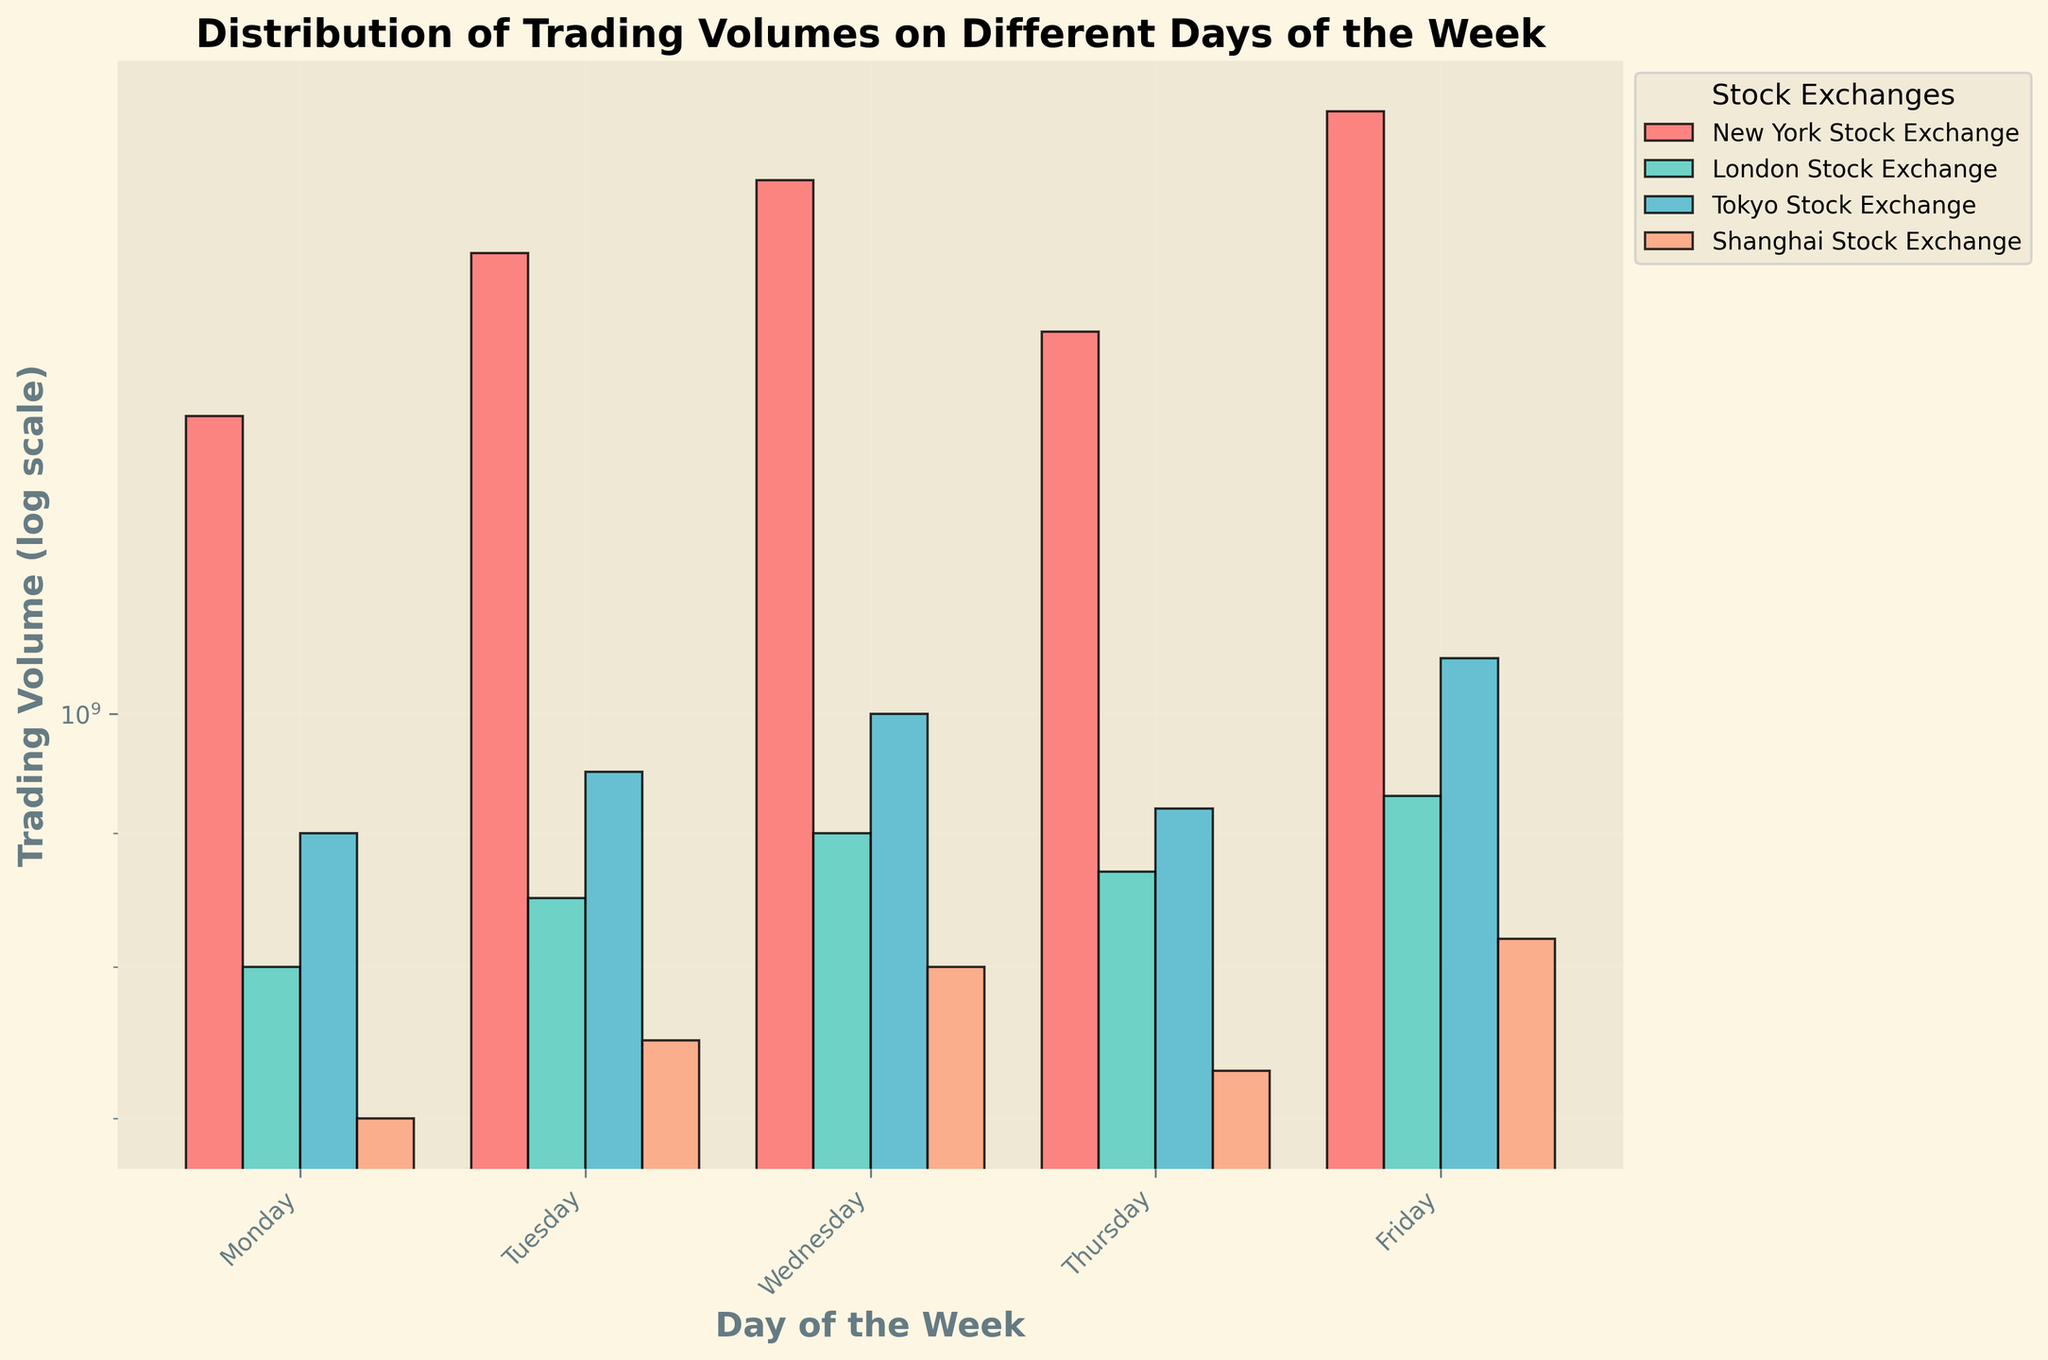Which market has the highest trading volume on Friday? By looking at the bars for Friday, the market with the tallest bar represents the highest trading volume. The New York Stock Exchange has the highest trading volume on Friday with its bar being the tallest.
Answer: New York Stock Exchange What is the trading volume difference between Monday and Friday for the Shanghai Stock Exchange? By examining the height of the bars for Monday and Friday for the Shanghai Stock Exchange, we find that Monday's volume is 700,000,000 and Friday's volume is 820,000,000. The difference is 820,000,000 - 700,000,000 = 120,000,000.
Answer: 120,000,000 On which day does the London Stock Exchange have the lowest trading volume? The bar for each day representing the London Stock Exchange should be compared. The lowest bar is on Monday, indicating that's the day with the lowest trading volume.
Answer: Monday What is the average trading volume for the Tokyo Stock Exchange from Monday to Friday? Summing the trading volumes for the Tokyo Stock Exchange across all days (Monday: 900,000,000; Tuesday: 950,000,000; Wednesday: 1,000,000,000; Thursday: 920,000,000; Friday: 1,050,000,000) and dividing by the number of days, the average is (900,000,000 + 950,000,000 + 1,000,000,000 + 920,000,000 + 1,050,000,000) / 5 = 964,000,000.
Answer: 964,000,000 Which day has the highest overall trading volume across all markets combined? By summing the volumes for all markets for each day of the week, we can determine the day with the highest overall volume. Summing the volumes for each market on Friday (1,700,000,000 + 930,000,000 + 1,050,000,000 + 820,000,000), the total is 4,500,000,000 which is greater compared to the other days.
Answer: Friday Which market shows the most consistent trading volume throughout the week? By examining the height and stability of the bars representing each market across all days, the Tokyo Stock Exchange has the least variability in bar heights, indicating consistent trading volume.
Answer: Tokyo Stock Exchange On which day does the New York Stock Exchange see a dip in its trading volume? By comparing the height of the bars for the New York Stock Exchange across all days, Thursday has a lower bar compared to the other days.
Answer: Thursday 